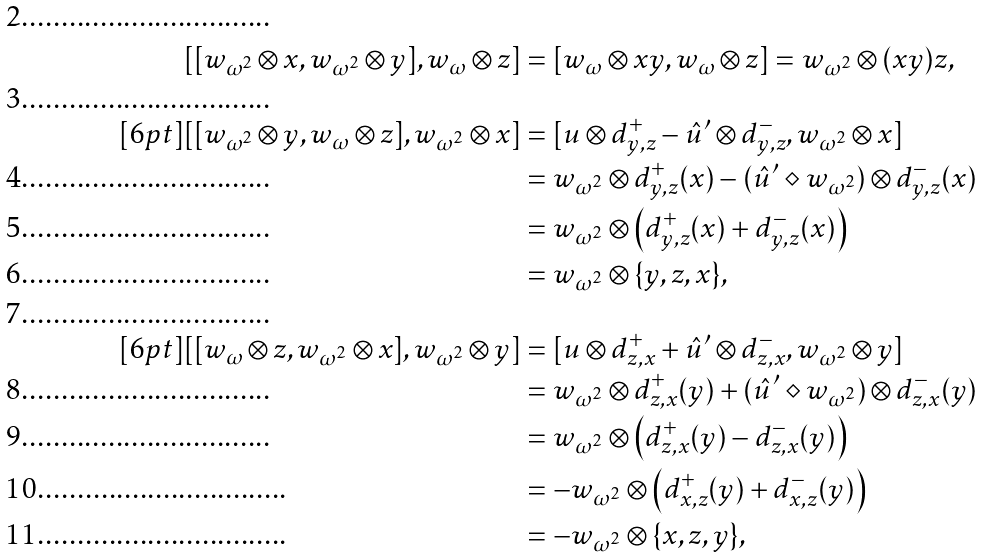Convert formula to latex. <formula><loc_0><loc_0><loc_500><loc_500>[ [ w _ { \omega ^ { 2 } } \otimes x , w _ { \omega ^ { 2 } } \otimes y ] , w _ { \omega } \otimes z ] & = [ w _ { \omega } \otimes x y , w _ { \omega } \otimes z ] = w _ { \omega ^ { 2 } } \otimes ( x y ) z , \\ [ 6 p t ] [ [ w _ { \omega ^ { 2 } } \otimes y , w _ { \omega } \otimes z ] , w _ { \omega ^ { 2 } } \otimes x ] & = [ u \otimes d _ { y , z } ^ { + } - \hat { u } ^ { \prime } \otimes d _ { y , z } ^ { - } , w _ { \omega ^ { 2 } } \otimes x ] \\ & = w _ { \omega ^ { 2 } } \otimes d _ { y , z } ^ { + } ( x ) - ( \hat { u } ^ { \prime } \diamond w _ { \omega ^ { 2 } } ) \otimes d _ { y , z } ^ { - } ( x ) \\ & = w _ { \omega ^ { 2 } } \otimes \left ( d _ { y , z } ^ { + } ( x ) + d _ { y , z } ^ { - } ( x ) \right ) \\ & = w _ { \omega ^ { 2 } } \otimes \{ y , z , x \} , \\ [ 6 p t ] [ [ w _ { \omega } \otimes z , w _ { \omega ^ { 2 } } \otimes x ] , w _ { \omega ^ { 2 } } \otimes y ] & = [ u \otimes d _ { z , x } ^ { + } + \hat { u } ^ { \prime } \otimes d _ { z , x } ^ { - } , w _ { \omega ^ { 2 } } \otimes y ] \\ & = w _ { \omega ^ { 2 } } \otimes d _ { z , x } ^ { + } ( y ) + ( \hat { u } ^ { \prime } \diamond w _ { \omega ^ { 2 } } ) \otimes d _ { z , x } ^ { - } ( y ) \\ & = w _ { \omega ^ { 2 } } \otimes \left ( d _ { z , x } ^ { + } ( y ) - d _ { z , x } ^ { - } ( y ) \right ) \\ & = - w _ { \omega ^ { 2 } } \otimes \left ( d _ { x , z } ^ { + } ( y ) + d _ { x , z } ^ { - } ( y ) \right ) \\ & = - w _ { \omega ^ { 2 } } \otimes \{ x , z , y \} ,</formula> 